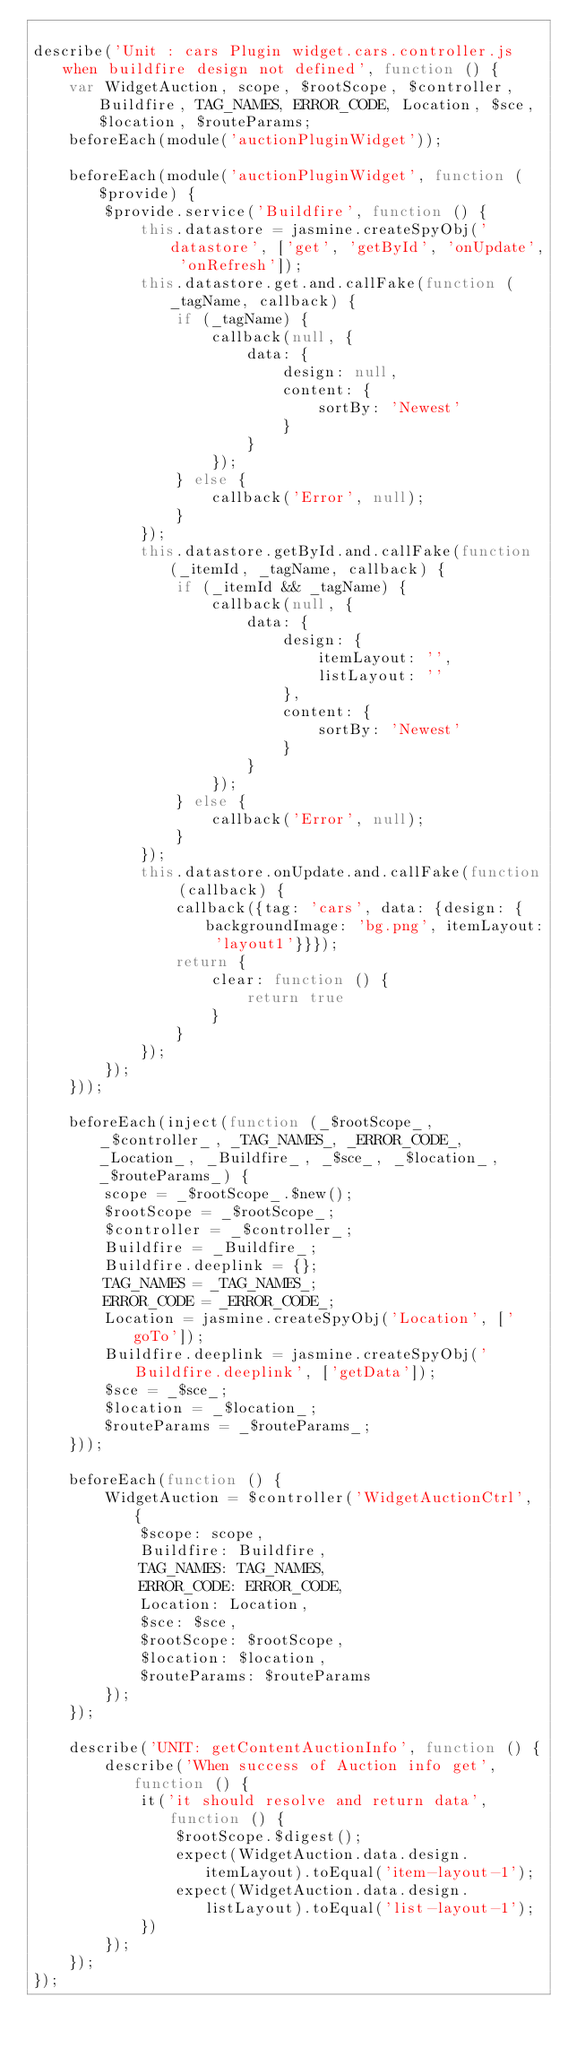Convert code to text. <code><loc_0><loc_0><loc_500><loc_500><_JavaScript_>
describe('Unit : cars Plugin widget.cars.controller.js when buildfire design not defined', function () {
    var WidgetAuction, scope, $rootScope, $controller, Buildfire, TAG_NAMES, ERROR_CODE, Location, $sce, $location, $routeParams;
    beforeEach(module('auctionPluginWidget'));

    beforeEach(module('auctionPluginWidget', function ($provide) {
        $provide.service('Buildfire', function () {
            this.datastore = jasmine.createSpyObj('datastore', ['get', 'getById', 'onUpdate', 'onRefresh']);
            this.datastore.get.and.callFake(function (_tagName, callback) {
                if (_tagName) {
                    callback(null, {
                        data: {
                            design: null,
                            content: {
                                sortBy: 'Newest'
                            }
                        }
                    });
                } else {
                    callback('Error', null);
                }
            });
            this.datastore.getById.and.callFake(function (_itemId, _tagName, callback) {
                if (_itemId && _tagName) {
                    callback(null, {
                        data: {
                            design: {
                                itemLayout: '',
                                listLayout: ''
                            },
                            content: {
                                sortBy: 'Newest'
                            }
                        }
                    });
                } else {
                    callback('Error', null);
                }
            });
            this.datastore.onUpdate.and.callFake(function (callback) {
                callback({tag: 'cars', data: {design: {backgroundImage: 'bg.png', itemLayout: 'layout1'}}});
                return {
                    clear: function () {
                        return true
                    }
                }
            });
        });
    }));

    beforeEach(inject(function (_$rootScope_, _$controller_, _TAG_NAMES_, _ERROR_CODE_, _Location_, _Buildfire_, _$sce_, _$location_, _$routeParams_) {
        scope = _$rootScope_.$new();
        $rootScope = _$rootScope_;
        $controller = _$controller_;
        Buildfire = _Buildfire_;
        Buildfire.deeplink = {};
        TAG_NAMES = _TAG_NAMES_;
        ERROR_CODE = _ERROR_CODE_;
        Location = jasmine.createSpyObj('Location', ['goTo']);
        Buildfire.deeplink = jasmine.createSpyObj('Buildfire.deeplink', ['getData']);
        $sce = _$sce_;
        $location = _$location_;
        $routeParams = _$routeParams_;
    }));

    beforeEach(function () {
        WidgetAuction = $controller('WidgetAuctionCtrl', {
            $scope: scope,
            Buildfire: Buildfire,
            TAG_NAMES: TAG_NAMES,
            ERROR_CODE: ERROR_CODE,
            Location: Location,
            $sce: $sce,
            $rootScope: $rootScope,
            $location: $location,
            $routeParams: $routeParams
        });
    });

    describe('UNIT: getContentAuctionInfo', function () {
        describe('When success of Auction info get', function () {
            it('it should resolve and return data', function () {
                $rootScope.$digest();
                expect(WidgetAuction.data.design.itemLayout).toEqual('item-layout-1');
                expect(WidgetAuction.data.design.listLayout).toEqual('list-layout-1');
            })
        });
    });
});</code> 